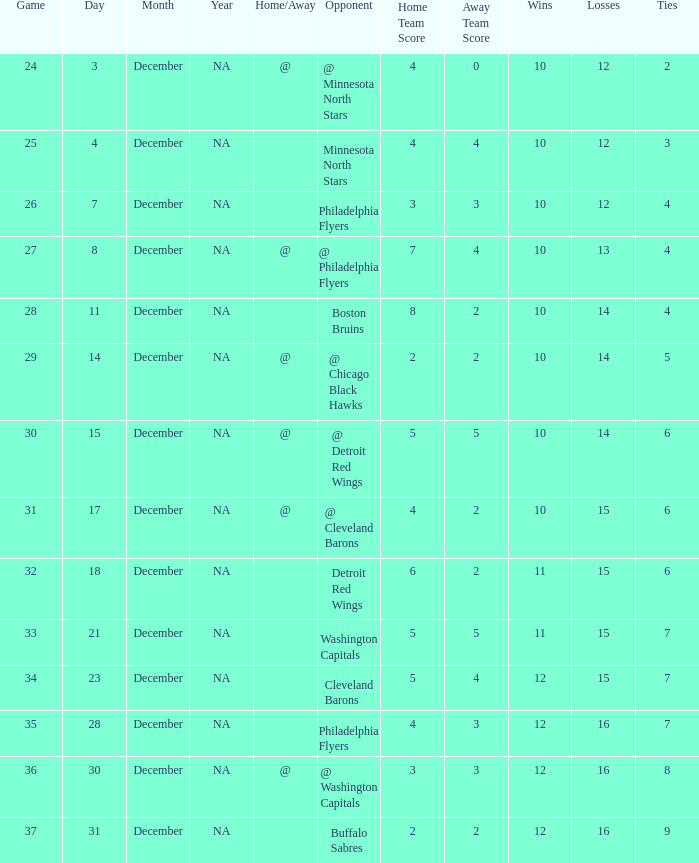What is Opponent, when Game is "37"? Buffalo Sabres. 